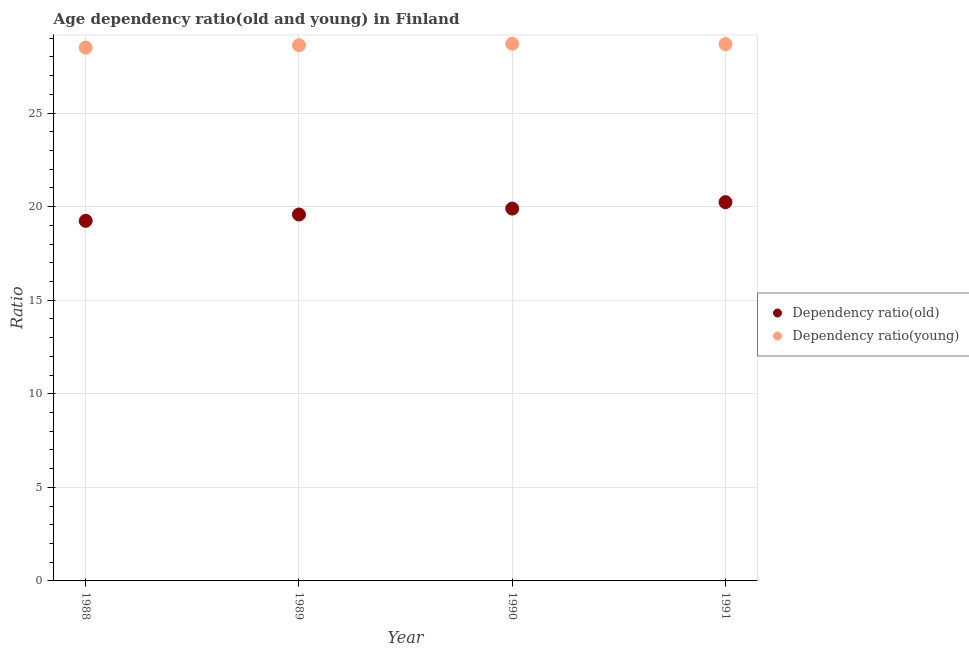Is the number of dotlines equal to the number of legend labels?
Your answer should be compact. Yes. What is the age dependency ratio(old) in 1989?
Give a very brief answer. 19.58. Across all years, what is the maximum age dependency ratio(young)?
Your response must be concise. 28.7. Across all years, what is the minimum age dependency ratio(old)?
Offer a very short reply. 19.24. In which year was the age dependency ratio(old) maximum?
Keep it short and to the point. 1991. What is the total age dependency ratio(young) in the graph?
Keep it short and to the point. 114.51. What is the difference between the age dependency ratio(old) in 1988 and that in 1989?
Make the answer very short. -0.34. What is the difference between the age dependency ratio(old) in 1990 and the age dependency ratio(young) in 1988?
Make the answer very short. -8.61. What is the average age dependency ratio(young) per year?
Your answer should be compact. 28.63. In the year 1989, what is the difference between the age dependency ratio(old) and age dependency ratio(young)?
Provide a succinct answer. -9.05. In how many years, is the age dependency ratio(old) greater than 25?
Offer a terse response. 0. What is the ratio of the age dependency ratio(young) in 1988 to that in 1990?
Offer a very short reply. 0.99. Is the age dependency ratio(young) in 1988 less than that in 1989?
Your response must be concise. Yes. Is the difference between the age dependency ratio(young) in 1990 and 1991 greater than the difference between the age dependency ratio(old) in 1990 and 1991?
Provide a short and direct response. Yes. What is the difference between the highest and the second highest age dependency ratio(young)?
Provide a short and direct response. 0.02. What is the difference between the highest and the lowest age dependency ratio(young)?
Ensure brevity in your answer.  0.2. Is the sum of the age dependency ratio(young) in 1990 and 1991 greater than the maximum age dependency ratio(old) across all years?
Give a very brief answer. Yes. Is the age dependency ratio(old) strictly greater than the age dependency ratio(young) over the years?
Make the answer very short. No. How many dotlines are there?
Make the answer very short. 2. How many years are there in the graph?
Give a very brief answer. 4. Are the values on the major ticks of Y-axis written in scientific E-notation?
Provide a short and direct response. No. Does the graph contain any zero values?
Offer a terse response. No. How many legend labels are there?
Provide a short and direct response. 2. What is the title of the graph?
Offer a very short reply. Age dependency ratio(old and young) in Finland. What is the label or title of the X-axis?
Provide a short and direct response. Year. What is the label or title of the Y-axis?
Your response must be concise. Ratio. What is the Ratio of Dependency ratio(old) in 1988?
Keep it short and to the point. 19.24. What is the Ratio of Dependency ratio(young) in 1988?
Provide a succinct answer. 28.5. What is the Ratio of Dependency ratio(old) in 1989?
Offer a very short reply. 19.58. What is the Ratio of Dependency ratio(young) in 1989?
Provide a succinct answer. 28.63. What is the Ratio of Dependency ratio(old) in 1990?
Provide a short and direct response. 19.9. What is the Ratio in Dependency ratio(young) in 1990?
Your response must be concise. 28.7. What is the Ratio in Dependency ratio(old) in 1991?
Offer a very short reply. 20.24. What is the Ratio of Dependency ratio(young) in 1991?
Offer a very short reply. 28.68. Across all years, what is the maximum Ratio in Dependency ratio(old)?
Keep it short and to the point. 20.24. Across all years, what is the maximum Ratio in Dependency ratio(young)?
Make the answer very short. 28.7. Across all years, what is the minimum Ratio in Dependency ratio(old)?
Give a very brief answer. 19.24. Across all years, what is the minimum Ratio in Dependency ratio(young)?
Make the answer very short. 28.5. What is the total Ratio in Dependency ratio(old) in the graph?
Your response must be concise. 78.95. What is the total Ratio in Dependency ratio(young) in the graph?
Your answer should be very brief. 114.51. What is the difference between the Ratio in Dependency ratio(old) in 1988 and that in 1989?
Give a very brief answer. -0.34. What is the difference between the Ratio of Dependency ratio(young) in 1988 and that in 1989?
Offer a very short reply. -0.12. What is the difference between the Ratio of Dependency ratio(old) in 1988 and that in 1990?
Your answer should be compact. -0.65. What is the difference between the Ratio of Dependency ratio(young) in 1988 and that in 1990?
Your answer should be compact. -0.2. What is the difference between the Ratio in Dependency ratio(old) in 1988 and that in 1991?
Your response must be concise. -1. What is the difference between the Ratio in Dependency ratio(young) in 1988 and that in 1991?
Ensure brevity in your answer.  -0.18. What is the difference between the Ratio of Dependency ratio(old) in 1989 and that in 1990?
Your answer should be very brief. -0.32. What is the difference between the Ratio of Dependency ratio(young) in 1989 and that in 1990?
Ensure brevity in your answer.  -0.08. What is the difference between the Ratio in Dependency ratio(old) in 1989 and that in 1991?
Provide a short and direct response. -0.66. What is the difference between the Ratio in Dependency ratio(young) in 1989 and that in 1991?
Ensure brevity in your answer.  -0.06. What is the difference between the Ratio in Dependency ratio(old) in 1990 and that in 1991?
Offer a very short reply. -0.34. What is the difference between the Ratio of Dependency ratio(young) in 1990 and that in 1991?
Your answer should be very brief. 0.02. What is the difference between the Ratio of Dependency ratio(old) in 1988 and the Ratio of Dependency ratio(young) in 1989?
Provide a short and direct response. -9.38. What is the difference between the Ratio of Dependency ratio(old) in 1988 and the Ratio of Dependency ratio(young) in 1990?
Your answer should be very brief. -9.46. What is the difference between the Ratio of Dependency ratio(old) in 1988 and the Ratio of Dependency ratio(young) in 1991?
Offer a terse response. -9.44. What is the difference between the Ratio in Dependency ratio(old) in 1989 and the Ratio in Dependency ratio(young) in 1990?
Offer a very short reply. -9.12. What is the difference between the Ratio in Dependency ratio(old) in 1989 and the Ratio in Dependency ratio(young) in 1991?
Offer a very short reply. -9.1. What is the difference between the Ratio of Dependency ratio(old) in 1990 and the Ratio of Dependency ratio(young) in 1991?
Keep it short and to the point. -8.79. What is the average Ratio of Dependency ratio(old) per year?
Provide a short and direct response. 19.74. What is the average Ratio in Dependency ratio(young) per year?
Your response must be concise. 28.63. In the year 1988, what is the difference between the Ratio in Dependency ratio(old) and Ratio in Dependency ratio(young)?
Your answer should be very brief. -9.26. In the year 1989, what is the difference between the Ratio in Dependency ratio(old) and Ratio in Dependency ratio(young)?
Your answer should be very brief. -9.05. In the year 1990, what is the difference between the Ratio of Dependency ratio(old) and Ratio of Dependency ratio(young)?
Your answer should be very brief. -8.81. In the year 1991, what is the difference between the Ratio of Dependency ratio(old) and Ratio of Dependency ratio(young)?
Make the answer very short. -8.45. What is the ratio of the Ratio of Dependency ratio(old) in 1988 to that in 1989?
Keep it short and to the point. 0.98. What is the ratio of the Ratio of Dependency ratio(young) in 1988 to that in 1989?
Provide a short and direct response. 1. What is the ratio of the Ratio of Dependency ratio(old) in 1988 to that in 1990?
Your response must be concise. 0.97. What is the ratio of the Ratio of Dependency ratio(young) in 1988 to that in 1990?
Offer a terse response. 0.99. What is the ratio of the Ratio in Dependency ratio(old) in 1988 to that in 1991?
Your answer should be compact. 0.95. What is the ratio of the Ratio in Dependency ratio(old) in 1989 to that in 1990?
Provide a short and direct response. 0.98. What is the ratio of the Ratio of Dependency ratio(old) in 1989 to that in 1991?
Your response must be concise. 0.97. What is the ratio of the Ratio of Dependency ratio(young) in 1989 to that in 1991?
Your answer should be very brief. 1. What is the difference between the highest and the second highest Ratio of Dependency ratio(old)?
Offer a very short reply. 0.34. What is the difference between the highest and the second highest Ratio in Dependency ratio(young)?
Your response must be concise. 0.02. What is the difference between the highest and the lowest Ratio in Dependency ratio(young)?
Make the answer very short. 0.2. 